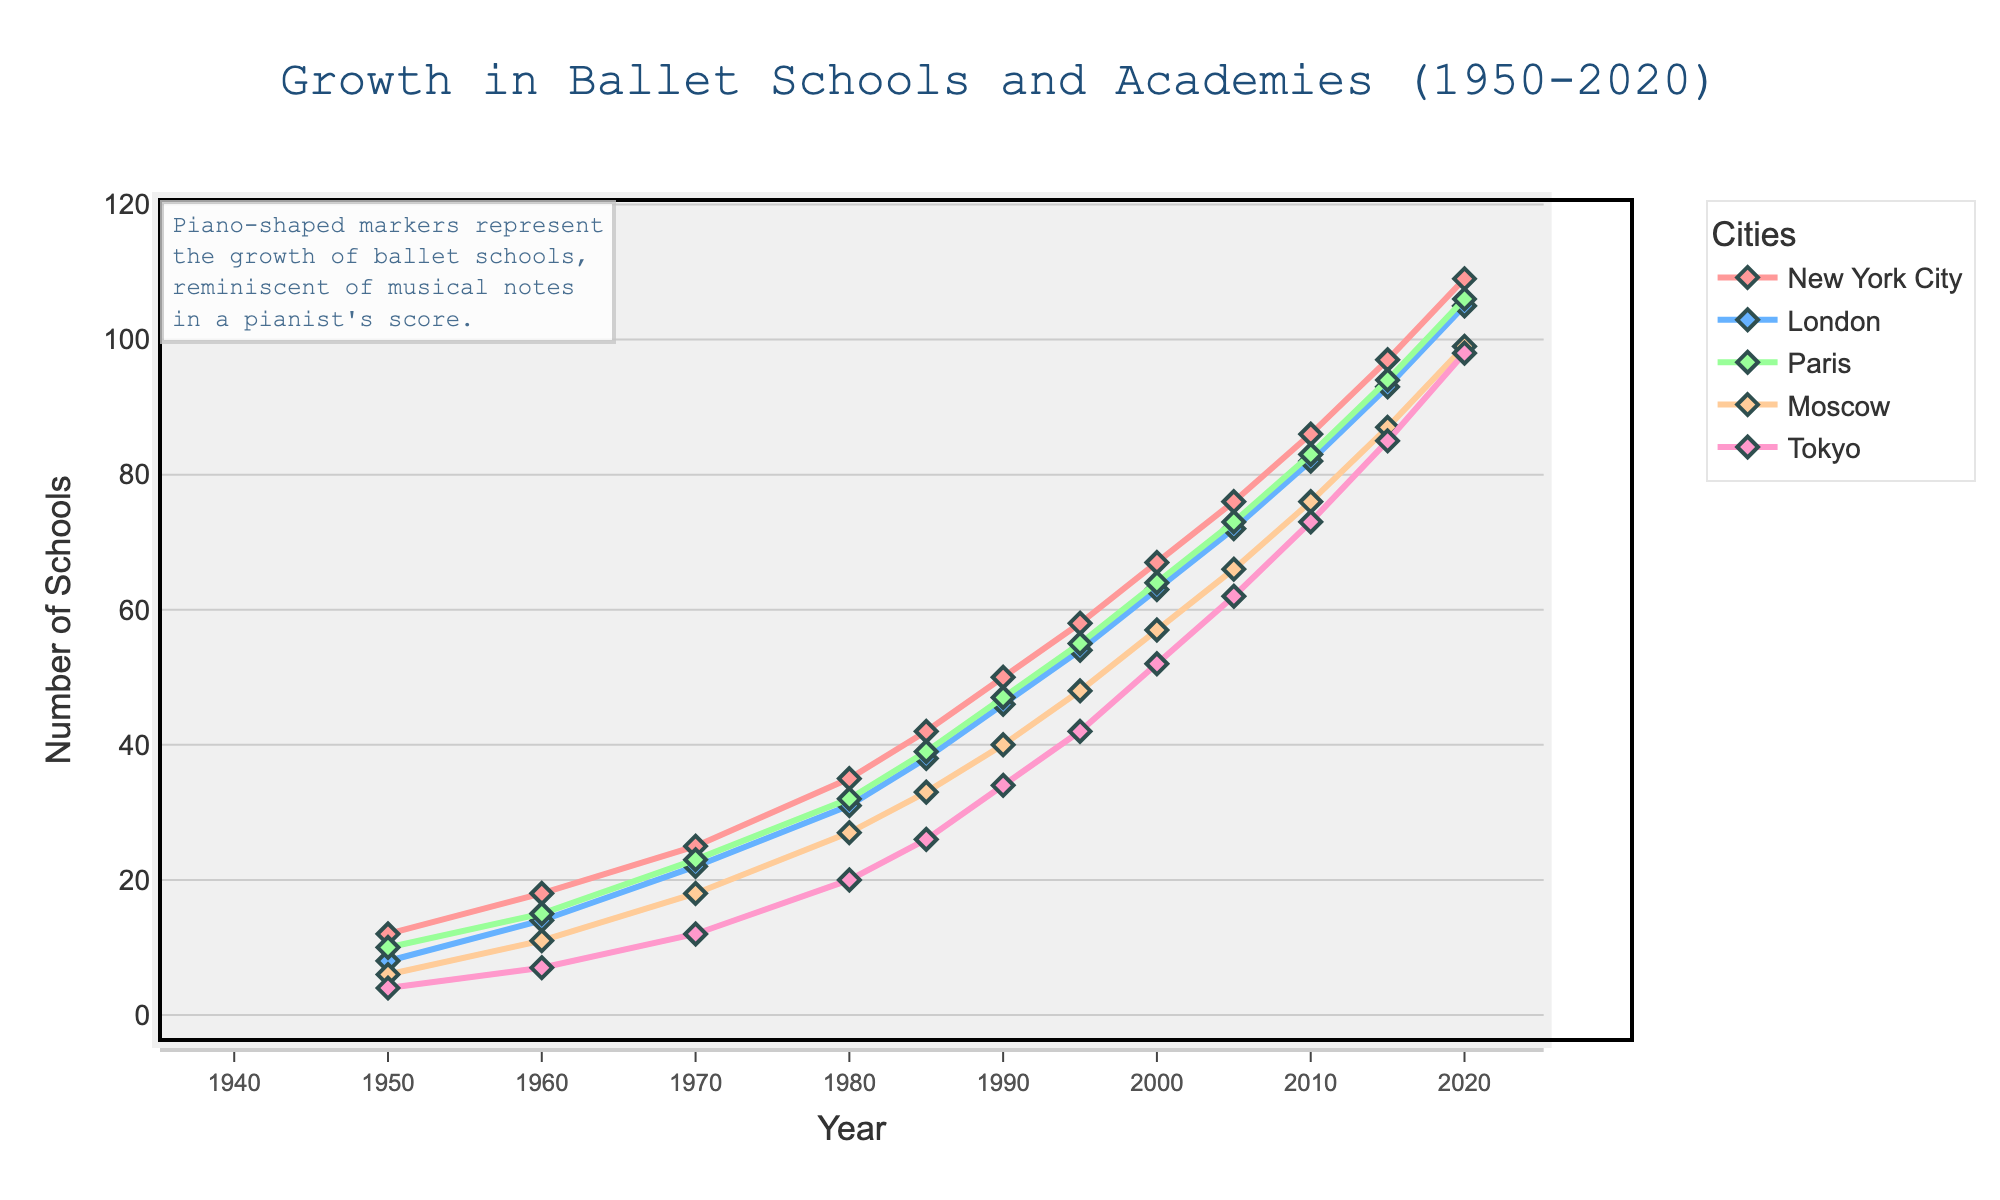What is the general trend for the number of ballet schools in New York City from 1950 to 2020? The line chart shows a steady upward trend in the number of ballet schools in New York City from 1950 to 2020, indicating continuous growth over these years.
Answer: Continuous growth Between 1950 and 2020, which city saw the largest increase in the number of ballet schools, and by how much? By comparing the starting and ending points of each city's line plot, we observe that New York City increased from 12 to 109. The difference is 109 - 12 = 97, which is the largest increase.
Answer: New York City, 97 Which city had the slowest growth in ballet schools from 1950 to 2020? By comparing the slopes of the lines for the five cities, it's evident that Tokyo had the gentlest slope, indicating the slowest growth in the number of ballet schools.
Answer: Tokyo Around what year did Moscow surpass Paris in the number of ballet schools? By visually inspecting the crossover point of the lines for Moscow and Paris, we see that Moscow surpassed Paris around the mid-1980s.
Answer: Mid-1980s What was the difference in the number of ballet schools in London and Moscow in the year 2000? From the figure, London had 63 schools and Moscow 57 in 2000. The difference is 63 - 57 = 6.
Answer: 6 How did the number of ballet schools in Tokyo change from 1970 to 2010? Referring to the point values in 1970 and 2010, Tokyo increased from 12 to 73. The change is 73 - 12 = 61.
Answer: Increased by 61 Which two cities had the closest number of ballet schools in 2020, and what were their respective numbers? By checking the endpoints of the line plots in 2020, London and Paris had the closest numbers, with 105 and 106 schools respectively.
Answer: London: 105, Paris: 106 Compare the number of ballet schools in Paris and New York City in 1985. Which city had more, and by how much? In 1985, Paris had 39 ballet schools, while New York City had 42. The difference is 42 - 39 = 3, with New York City having more.
Answer: New York City by 3 Calculate the average number of ballet schools across all five cities in 2020. Adding the school numbers for all cities in 2020: 109 (NYC) + 105 (London) + 106 (Paris) + 99 (Moscow) + 98 (Tokyo) = 517. The average is 517 / 5 = 103.4.
Answer: 103.4 Which city had the most significant growth rate between 1950 and 2000? The growth rate can be calculated by the percentage increase. For New York City, (67-12)/12 = 4.58 or 458%, which is higher than other cities when calculated similarly.
Answer: New York City 